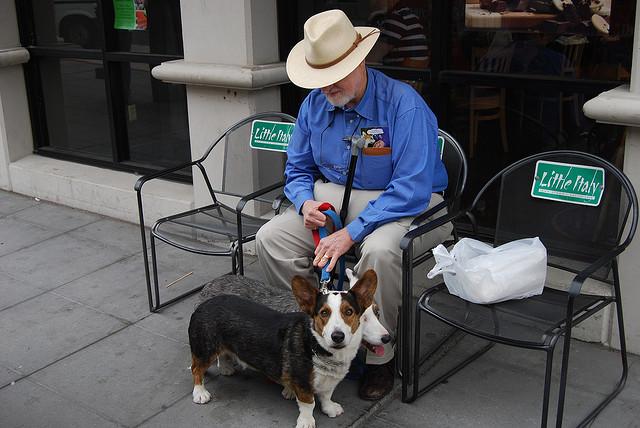Is he wearing a hat?
Concise answer only. Yes. Is the man walking the dog?
Keep it brief. Yes. How many dogs are there?
Quick response, please. 2. 